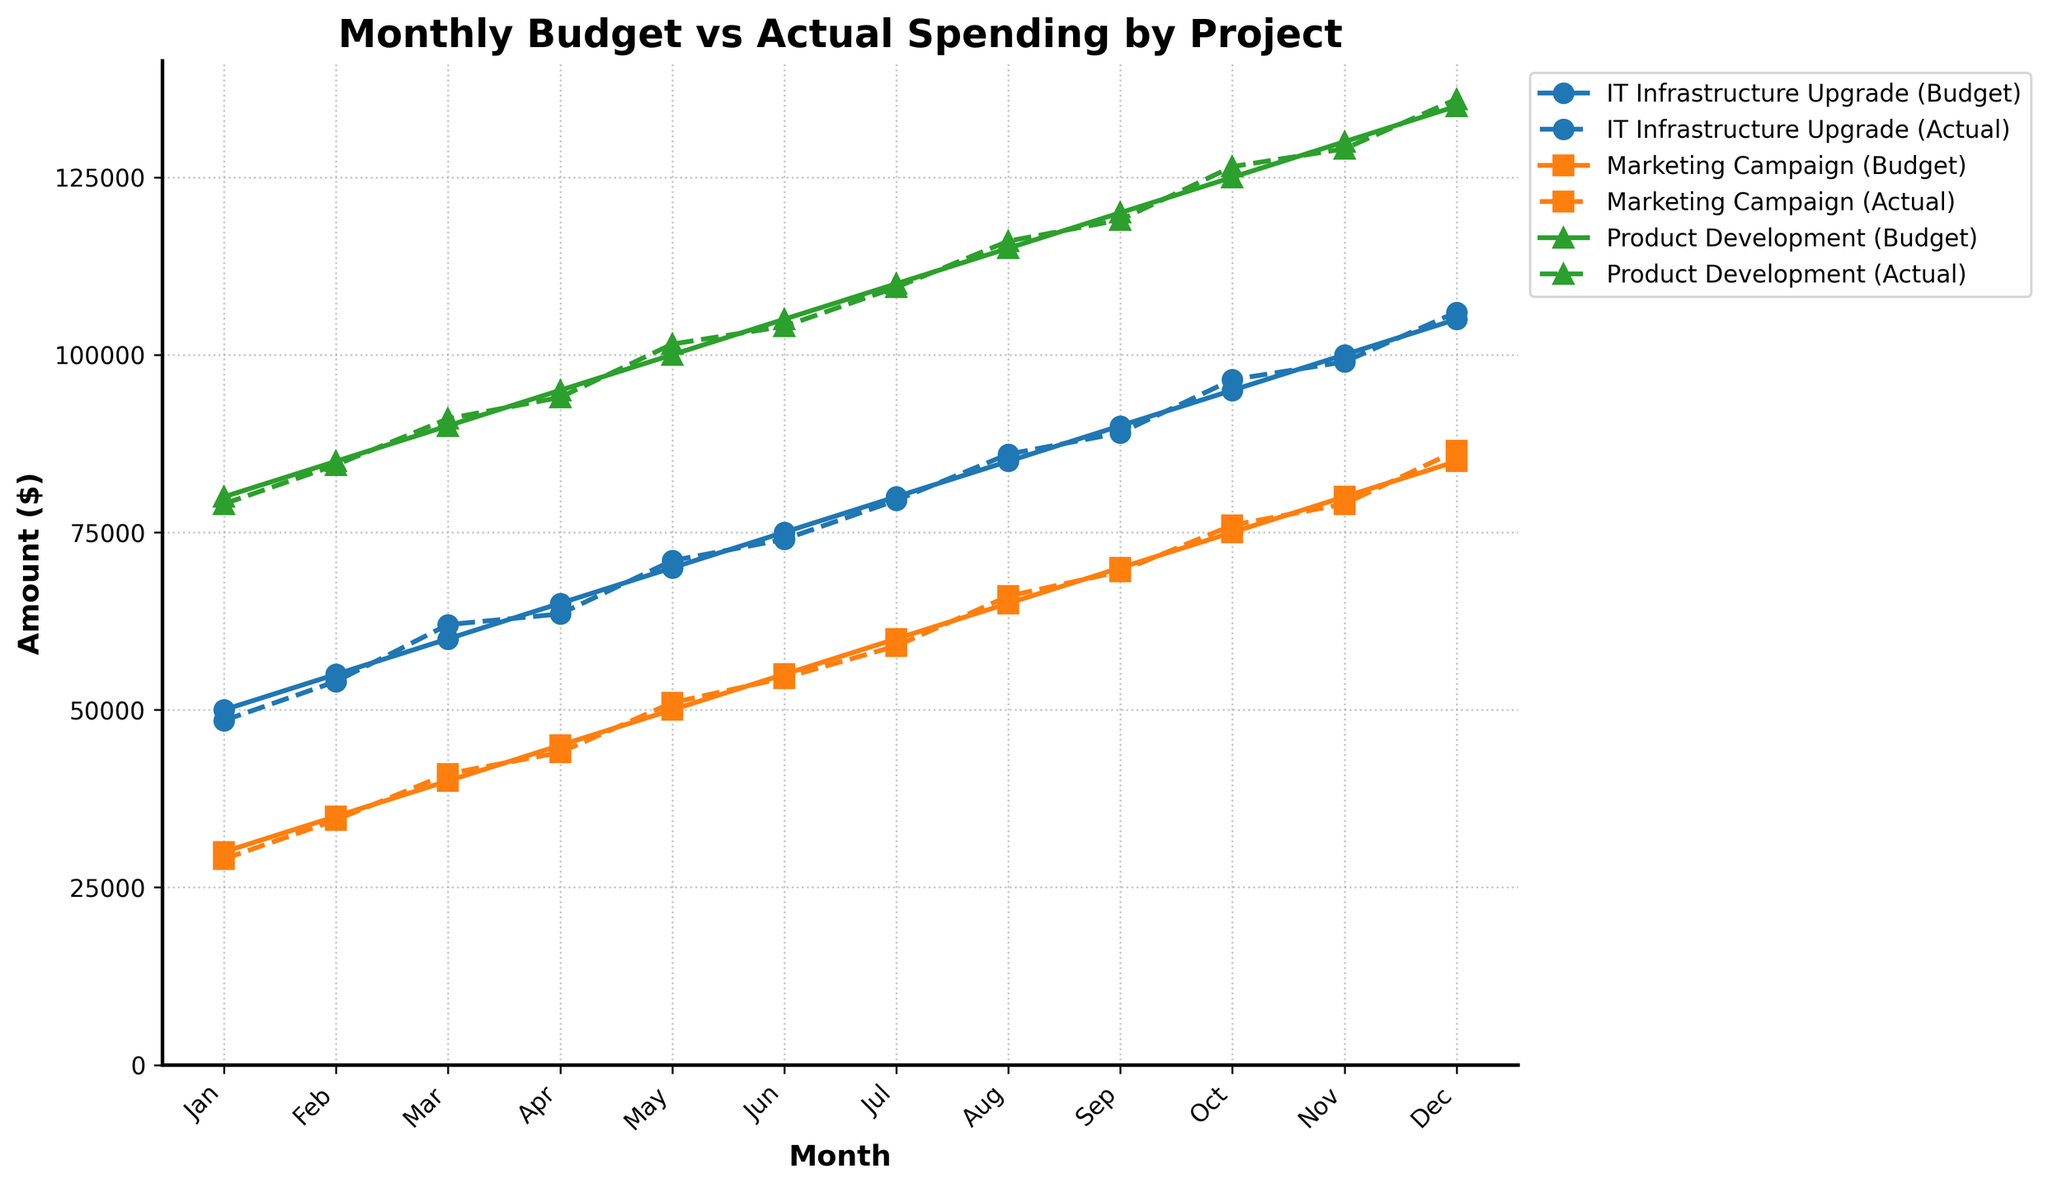What is the total budget allocated for the IT Infrastructure Upgrade from January to December? Sum the budget allocated each month for the IT Infrastructure Upgrade (50000 + 55000 + 60000 + 65000 + 70000 + 75000 + 80000 + 85000 + 90000 + 95000 + 100000 + 105000)
Answer: 960000 How does the Marketing Campaign's actual spending in October compare to its budget? Compare the actual spending and budget for the Marketing Campaign in October: Actual Spending (76000) vs Budget (75000), Actual Spending was 76000 - 75000 = 1000 more than the Budget
Answer: 1000 more Which project had the highest actual spending in December? Compare the actual spending for all projects in December: IT Infrastructure Upgrade (106000), Marketing Campaign (86500), Product Development (136000). The highest actual spending was for Product Development (136000)
Answer: Product Development Did any project consistently spend more than its budget every month? Observing the trend lines for each project: For IT Infrastructure Upgrade and Marketing Campaign, the Actual Spending was below Budget at least once. For Product Development, Actual Spending was always equal or higher than the Budget in every month, thus consistently spending more
Answer: Product Development What is the average difference between budget and actual spending for the Marketing Campaign over the fiscal year? Calculate the difference for each month, sum them up, and divide by the number of months to find the average: ((30000-29000) + (35000-34500) + (40000-41000) + (45000-44000) + (50000-51000) + (55000-54500) + (60000-59000) + (65000-66000) + (70000-69500) + (75000-76000) + (80000-79000) + (85000-86500)) / 12 = 250 / 12 = 20.83
Answer: 20.83 In which month did the IT Infrastructure Upgrade project experience the largest overspend? Identify the month with the largest positive difference between Actual Spending and Budget for IT Infrastructure Upgrade: March (62000 - 60000) = 2000, the largest among other months
Answer: March How does the total actual spending of Product Development compare to its total budget over the fiscal year? Sum the actual spending and budget for Product Development each month, then compare: Total Budget (80000 + 85000 + 90000 + 95000 + 100000 + 105000 + 110000 + 115000 + 120000 + 125000 + 130000 + 135000) = 1260000 vs Total Actual Spending (79000 + 84500 + 91000 + 94000 + 101500 + 104000 + 109500 + 116000 + 119000 + 126500 + 129000 + 136000) = 1262000. The actual spending is 1262000 - 1260000 = 2000 more
Answer: 2000 more How often did the Marketing Campaign's actual spending exceed its budget? Count the months where the actual spending was higher than the budget for the Marketing Campaign: March (41000 > 40000), May (51000 > 50000), August (66000 > 65000), October (76000 > 75000), December (86500 > 85000). This happened in 5 months
Answer: 5 months 